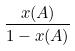Convert formula to latex. <formula><loc_0><loc_0><loc_500><loc_500>\frac { x ( A ) } { 1 - x ( A ) }</formula> 